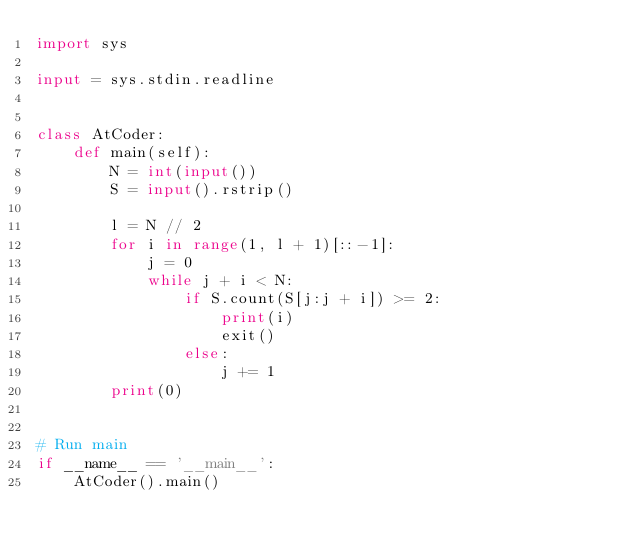Convert code to text. <code><loc_0><loc_0><loc_500><loc_500><_Python_>import sys

input = sys.stdin.readline


class AtCoder:
    def main(self):
        N = int(input())
        S = input().rstrip()

        l = N // 2
        for i in range(1, l + 1)[::-1]:
            j = 0
            while j + i < N:
                if S.count(S[j:j + i]) >= 2:
                    print(i)
                    exit()
                else:
                    j += 1
        print(0)


# Run main
if __name__ == '__main__':
    AtCoder().main()</code> 